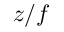Convert formula to latex. <formula><loc_0><loc_0><loc_500><loc_500>z / f</formula> 